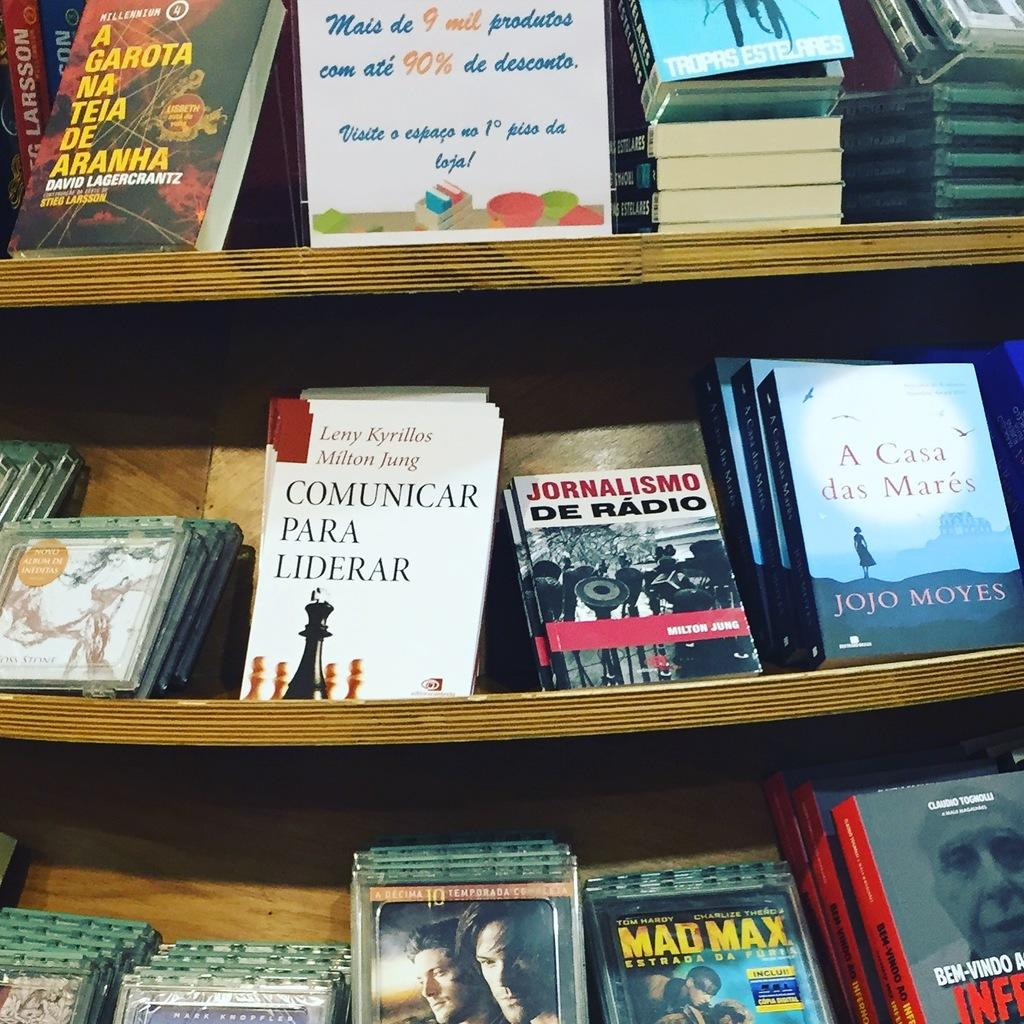<image>
Share a concise interpretation of the image provided. On the bottom shelf surrounded by books is the movie, Mad Max. 